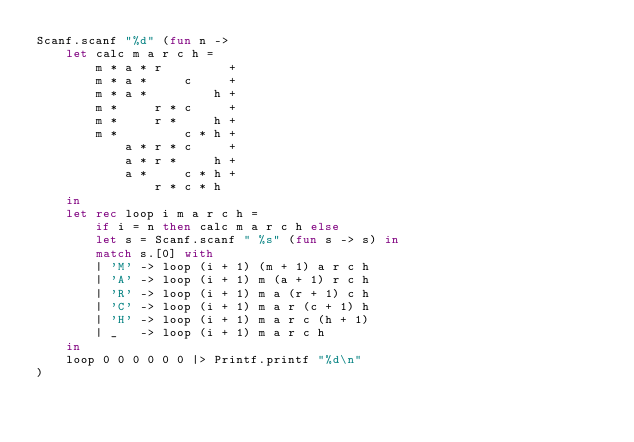Convert code to text. <code><loc_0><loc_0><loc_500><loc_500><_OCaml_>Scanf.scanf "%d" (fun n ->
    let calc m a r c h =
        m * a * r         +
        m * a *     c     +
        m * a *         h +
        m *     r * c     + 
        m *     r *     h +
        m *         c * h +
            a * r * c     +
            a * r *     h +
            a *     c * h +
                r * c * h
    in
    let rec loop i m a r c h =
        if i = n then calc m a r c h else
        let s = Scanf.scanf " %s" (fun s -> s) in
        match s.[0] with
        | 'M' -> loop (i + 1) (m + 1) a r c h
        | 'A' -> loop (i + 1) m (a + 1) r c h
        | 'R' -> loop (i + 1) m a (r + 1) c h
        | 'C' -> loop (i + 1) m a r (c + 1) h
        | 'H' -> loop (i + 1) m a r c (h + 1)
        | _   -> loop (i + 1) m a r c h
    in
    loop 0 0 0 0 0 0 |> Printf.printf "%d\n"
)</code> 